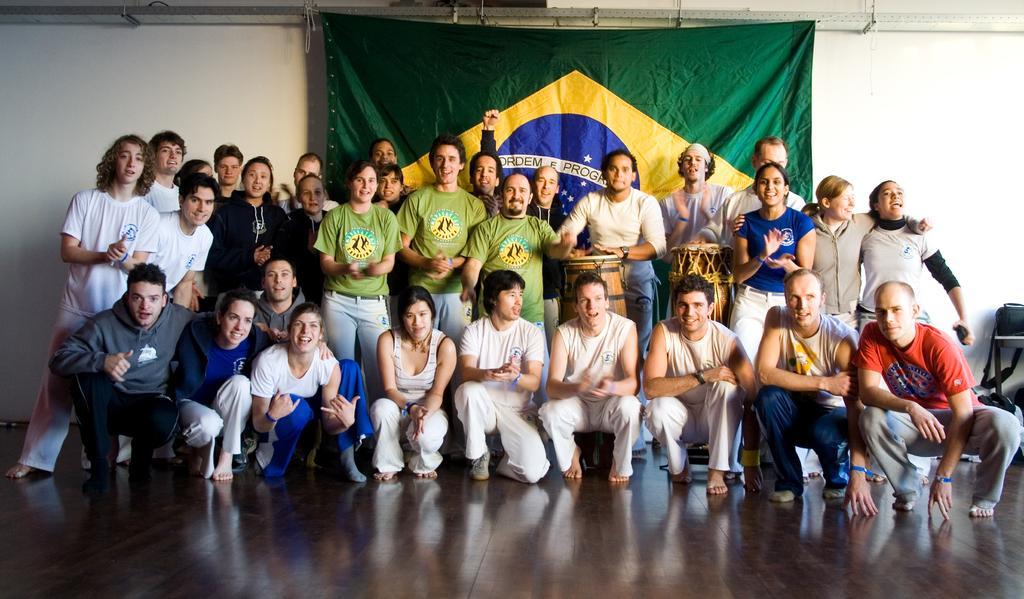How would you summarize this image in a sentence or two? In the center of the image we can see people standing and some of them are sitting. There are drums. In the background there is a cloth and a wall. 